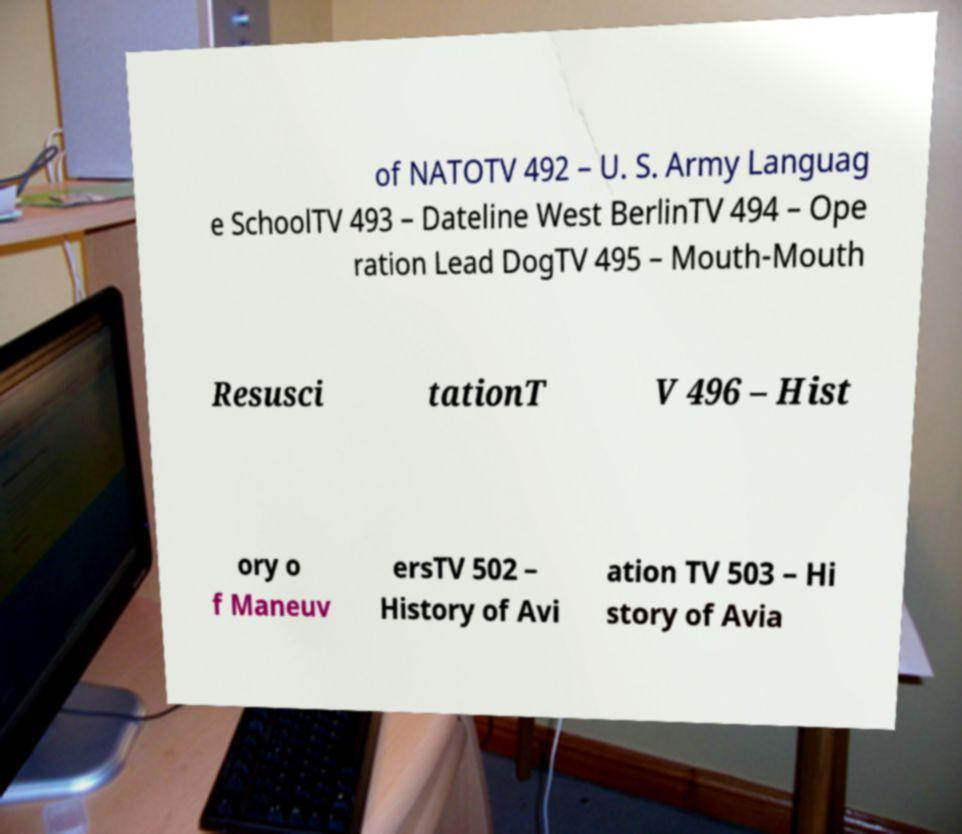Could you extract and type out the text from this image? of NATOTV 492 – U. S. Army Languag e SchoolTV 493 – Dateline West BerlinTV 494 – Ope ration Lead DogTV 495 – Mouth-Mouth Resusci tationT V 496 – Hist ory o f Maneuv ersTV 502 – History of Avi ation TV 503 – Hi story of Avia 